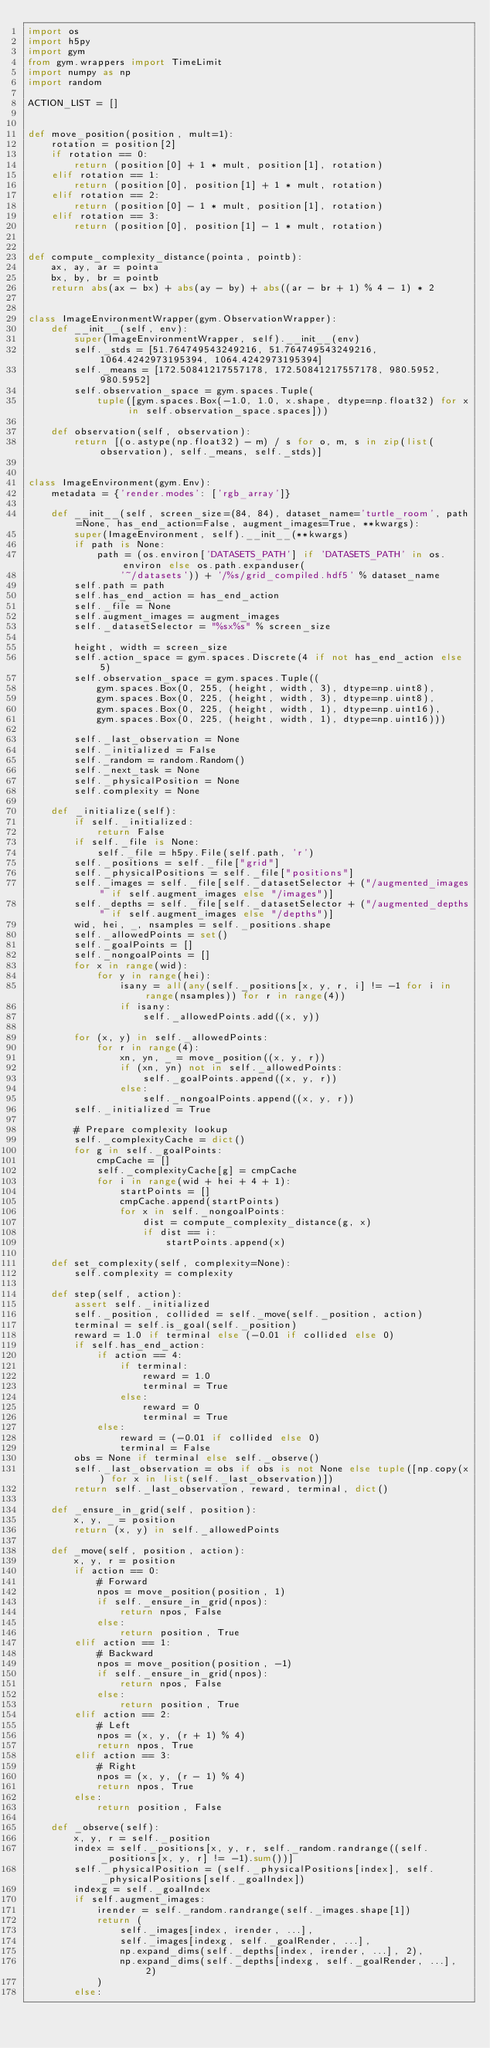<code> <loc_0><loc_0><loc_500><loc_500><_Python_>import os
import h5py
import gym
from gym.wrappers import TimeLimit
import numpy as np
import random

ACTION_LIST = []


def move_position(position, mult=1):
    rotation = position[2]
    if rotation == 0:
        return (position[0] + 1 * mult, position[1], rotation)
    elif rotation == 1:
        return (position[0], position[1] + 1 * mult, rotation)
    elif rotation == 2:
        return (position[0] - 1 * mult, position[1], rotation)
    elif rotation == 3:
        return (position[0], position[1] - 1 * mult, rotation)


def compute_complexity_distance(pointa, pointb):
    ax, ay, ar = pointa
    bx, by, br = pointb
    return abs(ax - bx) + abs(ay - by) + abs((ar - br + 1) % 4 - 1) * 2


class ImageEnvironmentWrapper(gym.ObservationWrapper):
    def __init__(self, env):
        super(ImageEnvironmentWrapper, self).__init__(env)
        self._stds = [51.764749543249216, 51.764749543249216, 1064.4242973195394, 1064.4242973195394]
        self._means = [172.50841217557178, 172.50841217557178, 980.5952, 980.5952]
        self.observation_space = gym.spaces.Tuple(
            tuple([gym.spaces.Box(-1.0, 1.0, x.shape, dtype=np.float32) for x in self.observation_space.spaces]))

    def observation(self, observation):
        return [(o.astype(np.float32) - m) / s for o, m, s in zip(list(observation), self._means, self._stds)]


class ImageEnvironment(gym.Env):
    metadata = {'render.modes': ['rgb_array']}

    def __init__(self, screen_size=(84, 84), dataset_name='turtle_room', path=None, has_end_action=False, augment_images=True, **kwargs):
        super(ImageEnvironment, self).__init__(**kwargs)
        if path is None:
            path = (os.environ['DATASETS_PATH'] if 'DATASETS_PATH' in os.environ else os.path.expanduser(
                '~/datasets')) + '/%s/grid_compiled.hdf5' % dataset_name
        self.path = path
        self.has_end_action = has_end_action
        self._file = None
        self.augment_images = augment_images
        self._datasetSelector = "%sx%s" % screen_size

        height, width = screen_size
        self.action_space = gym.spaces.Discrete(4 if not has_end_action else 5)
        self.observation_space = gym.spaces.Tuple((
            gym.spaces.Box(0, 255, (height, width, 3), dtype=np.uint8),
            gym.spaces.Box(0, 225, (height, width, 3), dtype=np.uint8),
            gym.spaces.Box(0, 225, (height, width, 1), dtype=np.uint16),
            gym.spaces.Box(0, 225, (height, width, 1), dtype=np.uint16)))

        self._last_observation = None
        self._initialized = False
        self._random = random.Random()
        self._next_task = None
        self._physicalPosition = None
        self.complexity = None

    def _initialize(self):
        if self._initialized:
            return False
        if self._file is None:
            self._file = h5py.File(self.path, 'r')
        self._positions = self._file["grid"]
        self._physicalPositions = self._file["positions"]
        self._images = self._file[self._datasetSelector + ("/augmented_images" if self.augment_images else "/images")]
        self._depths = self._file[self._datasetSelector + ("/augmented_depths" if self.augment_images else "/depths")]
        wid, hei, _, nsamples = self._positions.shape
        self._allowedPoints = set()
        self._goalPoints = []
        self._nongoalPoints = []
        for x in range(wid):
            for y in range(hei):
                isany = all(any(self._positions[x, y, r, i] != -1 for i in range(nsamples)) for r in range(4))
                if isany:
                    self._allowedPoints.add((x, y))

        for (x, y) in self._allowedPoints:
            for r in range(4):
                xn, yn, _ = move_position((x, y, r))
                if (xn, yn) not in self._allowedPoints:
                    self._goalPoints.append((x, y, r))
                else:
                    self._nongoalPoints.append((x, y, r))
        self._initialized = True

        # Prepare complexity lookup
        self._complexityCache = dict()
        for g in self._goalPoints:
            cmpCache = []
            self._complexityCache[g] = cmpCache
            for i in range(wid + hei + 4 + 1):
                startPoints = []
                cmpCache.append(startPoints)
                for x in self._nongoalPoints:
                    dist = compute_complexity_distance(g, x)
                    if dist == i:
                        startPoints.append(x)

    def set_complexity(self, complexity=None):
        self.complexity = complexity

    def step(self, action):
        assert self._initialized
        self._position, collided = self._move(self._position, action)
        terminal = self.is_goal(self._position)
        reward = 1.0 if terminal else (-0.01 if collided else 0)
        if self.has_end_action:
            if action == 4:
                if terminal:
                    reward = 1.0
                    terminal = True
                else:
                    reward = 0
                    terminal = True
            else:
                reward = (-0.01 if collided else 0)
                terminal = False
        obs = None if terminal else self._observe()
        self._last_observation = obs if obs is not None else tuple([np.copy(x) for x in list(self._last_observation)])
        return self._last_observation, reward, terminal, dict()

    def _ensure_in_grid(self, position):
        x, y, _ = position
        return (x, y) in self._allowedPoints

    def _move(self, position, action):
        x, y, r = position
        if action == 0:
            # Forward
            npos = move_position(position, 1)
            if self._ensure_in_grid(npos):
                return npos, False
            else:
                return position, True
        elif action == 1:
            # Backward
            npos = move_position(position, -1)
            if self._ensure_in_grid(npos):
                return npos, False
            else:
                return position, True
        elif action == 2:
            # Left
            npos = (x, y, (r + 1) % 4)
            return npos, True
        elif action == 3:
            # Right
            npos = (x, y, (r - 1) % 4)
            return npos, True
        else:
            return position, False

    def _observe(self):
        x, y, r = self._position
        index = self._positions[x, y, r, self._random.randrange((self._positions[x, y, r] != -1).sum())]
        self._physicalPosition = (self._physicalPositions[index], self._physicalPositions[self._goalIndex])
        indexg = self._goalIndex
        if self.augment_images:
            irender = self._random.randrange(self._images.shape[1])
            return (
                self._images[index, irender, ...],
                self._images[indexg, self._goalRender, ...],
                np.expand_dims(self._depths[index, irender, ...], 2),
                np.expand_dims(self._depths[indexg, self._goalRender, ...], 2)
            )
        else:</code> 